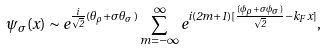<formula> <loc_0><loc_0><loc_500><loc_500>\psi _ { \sigma } ( x ) \sim e ^ { \frac { i } { \sqrt { 2 } } ( \theta _ { \rho } + \sigma \theta _ { \sigma } ) } \sum _ { m = - \infty } ^ { \infty } e ^ { i ( 2 m + 1 ) [ \frac { ( \phi _ { \rho } + \sigma \phi _ { \sigma } ) } { \sqrt { 2 } } - k _ { F } x ] } ,</formula> 